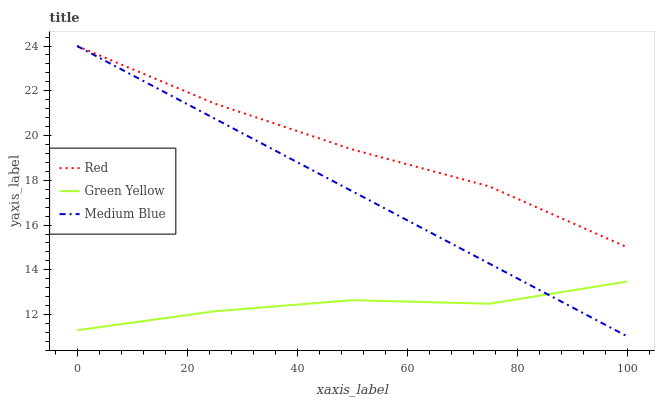Does Green Yellow have the minimum area under the curve?
Answer yes or no. Yes. Does Red have the maximum area under the curve?
Answer yes or no. Yes. Does Medium Blue have the minimum area under the curve?
Answer yes or no. No. Does Medium Blue have the maximum area under the curve?
Answer yes or no. No. Is Medium Blue the smoothest?
Answer yes or no. Yes. Is Green Yellow the roughest?
Answer yes or no. Yes. Is Red the smoothest?
Answer yes or no. No. Is Red the roughest?
Answer yes or no. No. Does Red have the lowest value?
Answer yes or no. No. Does Red have the highest value?
Answer yes or no. Yes. Is Green Yellow less than Red?
Answer yes or no. Yes. Is Red greater than Green Yellow?
Answer yes or no. Yes. Does Medium Blue intersect Red?
Answer yes or no. Yes. Is Medium Blue less than Red?
Answer yes or no. No. Is Medium Blue greater than Red?
Answer yes or no. No. Does Green Yellow intersect Red?
Answer yes or no. No. 